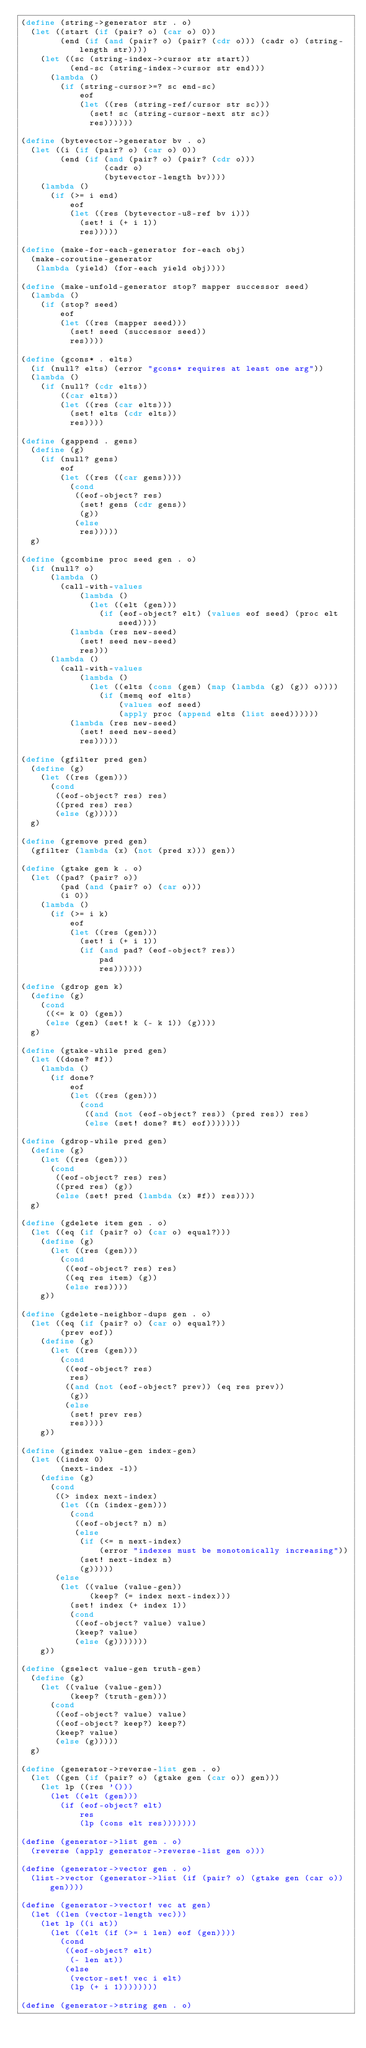<code> <loc_0><loc_0><loc_500><loc_500><_Scheme_>(define (string->generator str . o)
  (let ((start (if (pair? o) (car o) 0))
        (end (if (and (pair? o) (pair? (cdr o))) (cadr o) (string-length str))))
    (let ((sc (string-index->cursor str start))
          (end-sc (string-index->cursor str end)))
      (lambda ()
        (if (string-cursor>=? sc end-sc)
            eof
            (let ((res (string-ref/cursor str sc)))
              (set! sc (string-cursor-next str sc))
              res))))))

(define (bytevector->generator bv . o)
  (let ((i (if (pair? o) (car o) 0))
        (end (if (and (pair? o) (pair? (cdr o)))
                 (cadr o)
                 (bytevector-length bv))))
    (lambda ()
      (if (>= i end)
          eof
          (let ((res (bytevector-u8-ref bv i)))
            (set! i (+ i 1))
            res)))))

(define (make-for-each-generator for-each obj)
  (make-coroutine-generator
   (lambda (yield) (for-each yield obj))))

(define (make-unfold-generator stop? mapper successor seed)
  (lambda ()
    (if (stop? seed)
        eof
        (let ((res (mapper seed)))
          (set! seed (successor seed))
          res))))

(define (gcons* . elts)
  (if (null? elts) (error "gcons* requires at least one arg"))
  (lambda ()
    (if (null? (cdr elts))
        ((car elts))
        (let ((res (car elts)))
          (set! elts (cdr elts))
          res))))

(define (gappend . gens)
  (define (g)
    (if (null? gens)
        eof
        (let ((res ((car gens))))
          (cond
           ((eof-object? res)
            (set! gens (cdr gens))
            (g))
           (else
            res)))))
  g)

(define (gcombine proc seed gen . o)
  (if (null? o)
      (lambda ()
        (call-with-values
            (lambda ()
              (let ((elt (gen)))
                (if (eof-object? elt) (values eof seed) (proc elt seed))))
          (lambda (res new-seed)
            (set! seed new-seed)
            res)))
      (lambda ()
        (call-with-values
            (lambda ()
              (let ((elts (cons (gen) (map (lambda (g) (g)) o))))
                (if (memq eof elts)
                    (values eof seed)
                    (apply proc (append elts (list seed))))))
          (lambda (res new-seed)
            (set! seed new-seed)
            res)))))

(define (gfilter pred gen)
  (define (g)
    (let ((res (gen)))
      (cond
       ((eof-object? res) res)
       ((pred res) res)
       (else (g)))))
  g)

(define (gremove pred gen)
  (gfilter (lambda (x) (not (pred x))) gen))

(define (gtake gen k . o)
  (let ((pad? (pair? o))
        (pad (and (pair? o) (car o)))
        (i 0))
    (lambda ()
      (if (>= i k)
          eof
          (let ((res (gen)))
            (set! i (+ i 1))
            (if (and pad? (eof-object? res))
                pad
                res))))))

(define (gdrop gen k)
  (define (g)
    (cond
     ((<= k 0) (gen))
     (else (gen) (set! k (- k 1)) (g))))
  g)

(define (gtake-while pred gen)
  (let ((done? #f))
    (lambda ()
      (if done?
          eof
          (let ((res (gen)))
            (cond
             ((and (not (eof-object? res)) (pred res)) res)
             (else (set! done? #t) eof)))))))

(define (gdrop-while pred gen)
  (define (g)
    (let ((res (gen)))
      (cond
       ((eof-object? res) res)
       ((pred res) (g))
       (else (set! pred (lambda (x) #f)) res))))
  g)

(define (gdelete item gen . o)
  (let ((eq (if (pair? o) (car o) equal?)))
    (define (g)
      (let ((res (gen)))
        (cond
         ((eof-object? res) res)
         ((eq res item) (g))
         (else res))))
    g))

(define (gdelete-neighbor-dups gen . o)
  (let ((eq (if (pair? o) (car o) equal?))
        (prev eof))
    (define (g)
      (let ((res (gen)))
        (cond
         ((eof-object? res)
          res)
         ((and (not (eof-object? prev)) (eq res prev))
          (g))
         (else
          (set! prev res)
          res))))
    g))

(define (gindex value-gen index-gen)
  (let ((index 0)
        (next-index -1))
    (define (g)
      (cond
       ((> index next-index)
        (let ((n (index-gen)))
          (cond
           ((eof-object? n) n)
           (else
            (if (<= n next-index)
                (error "indexes must be monotonically increasing"))
            (set! next-index n)
            (g)))))
       (else
        (let ((value (value-gen))
              (keep? (= index next-index)))
          (set! index (+ index 1))
          (cond
           ((eof-object? value) value)
           (keep? value)
           (else (g)))))))
    g))

(define (gselect value-gen truth-gen)
  (define (g)
    (let ((value (value-gen))
          (keep? (truth-gen)))
      (cond
       ((eof-object? value) value)
       ((eof-object? keep?) keep?)
       (keep? value)
       (else (g)))))
  g)

(define (generator->reverse-list gen . o)
  (let ((gen (if (pair? o) (gtake gen (car o)) gen)))
    (let lp ((res '()))
      (let ((elt (gen)))
        (if (eof-object? elt)
            res
            (lp (cons elt res)))))))

(define (generator->list gen . o)
  (reverse (apply generator->reverse-list gen o)))

(define (generator->vector gen . o)
  (list->vector (generator->list (if (pair? o) (gtake gen (car o)) gen))))

(define (generator->vector! vec at gen)
  (let ((len (vector-length vec)))
    (let lp ((i at))
      (let ((elt (if (>= i len) eof (gen))))
        (cond
         ((eof-object? elt)
          (- len at))
         (else
          (vector-set! vec i elt)
          (lp (+ i 1))))))))

(define (generator->string gen . o)</code> 